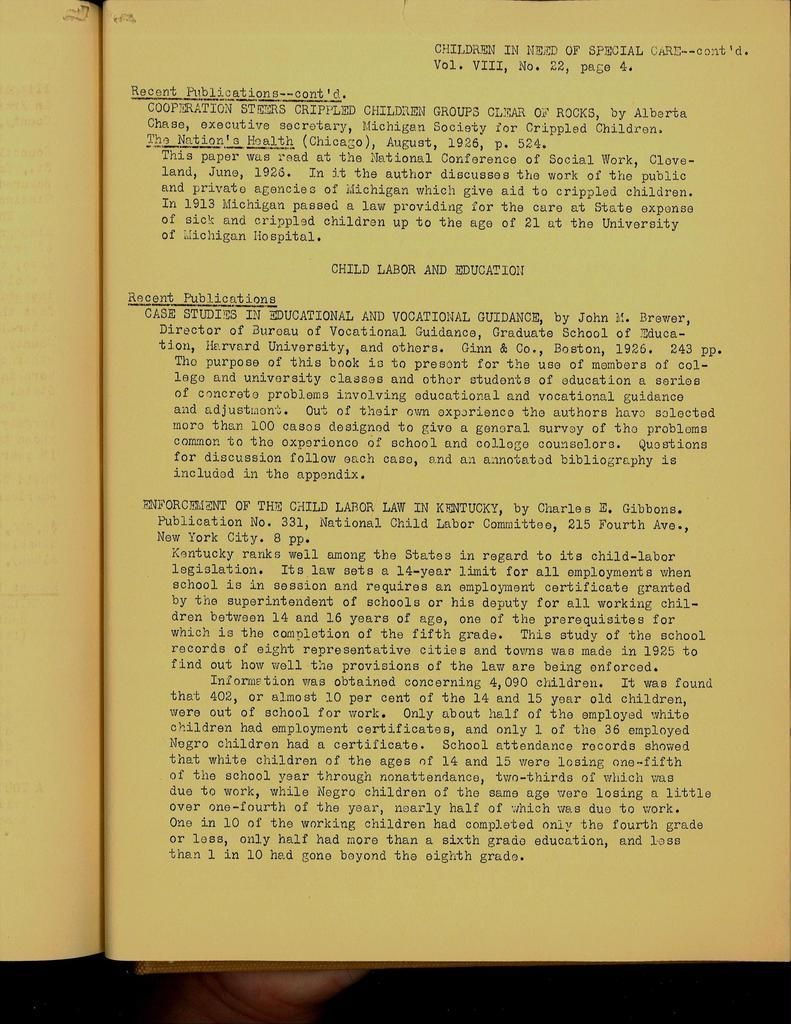<image>
Summarize the visual content of the image. A page of type with Children in Need Special written on the top. 